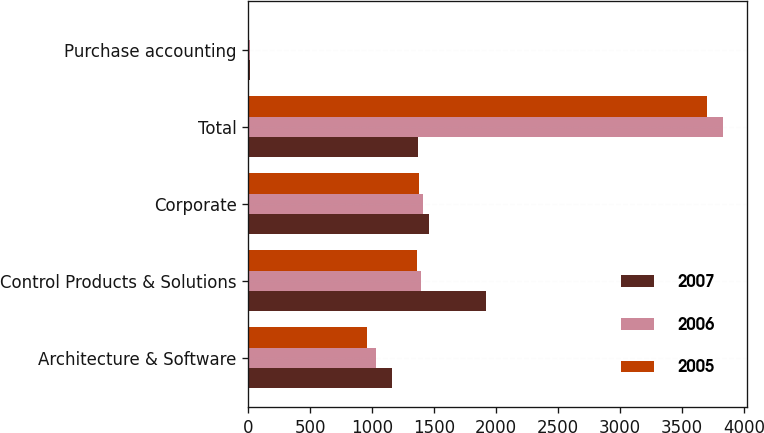Convert chart. <chart><loc_0><loc_0><loc_500><loc_500><stacked_bar_chart><ecel><fcel>Architecture & Software<fcel>Control Products & Solutions<fcel>Corporate<fcel>Total<fcel>Purchase accounting<nl><fcel>2007<fcel>1163.6<fcel>1921.3<fcel>1460.9<fcel>1372.2<fcel>16.4<nl><fcel>2006<fcel>1030<fcel>1391.5<fcel>1410.3<fcel>3831.8<fcel>10.6<nl><fcel>2005<fcel>956.5<fcel>1362.7<fcel>1381.7<fcel>3700.9<fcel>10<nl></chart> 